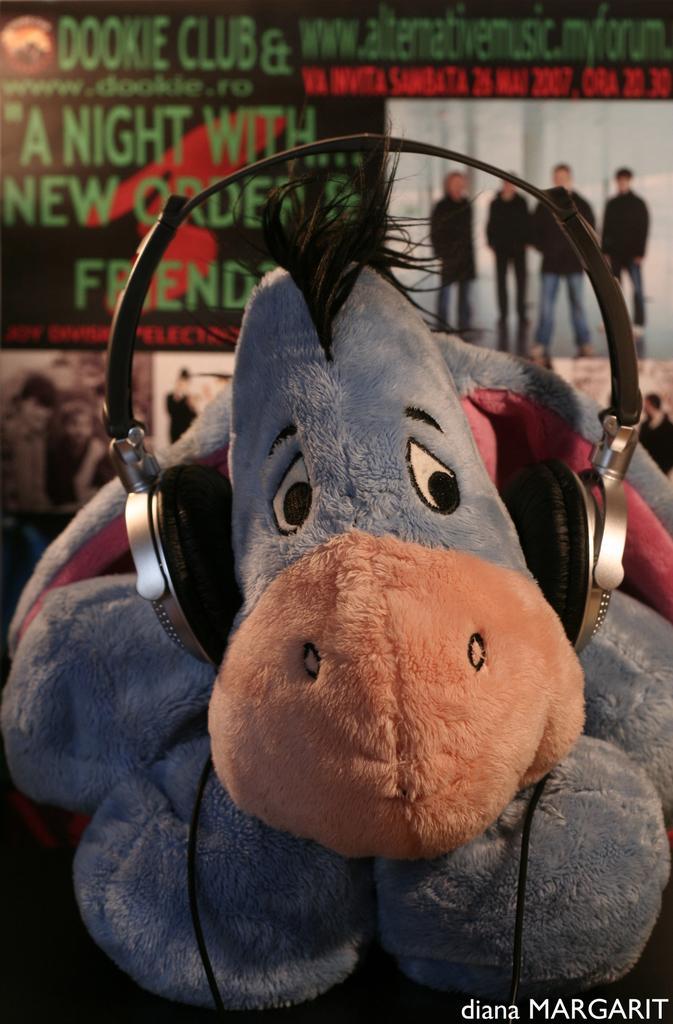In one or two sentences, can you explain what this image depicts? In this image I can see the toy is wearing headset. In the background I can see the poster in which I can see few people are standing and something is written on the poster. 